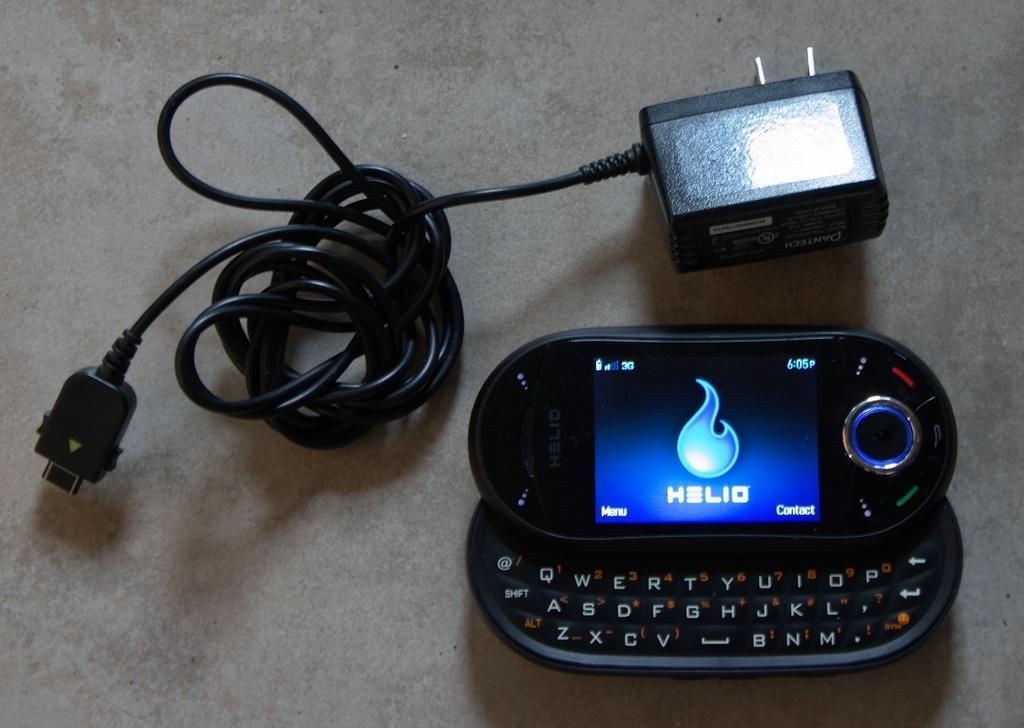What time is it?
Provide a short and direct response. 6:05. 